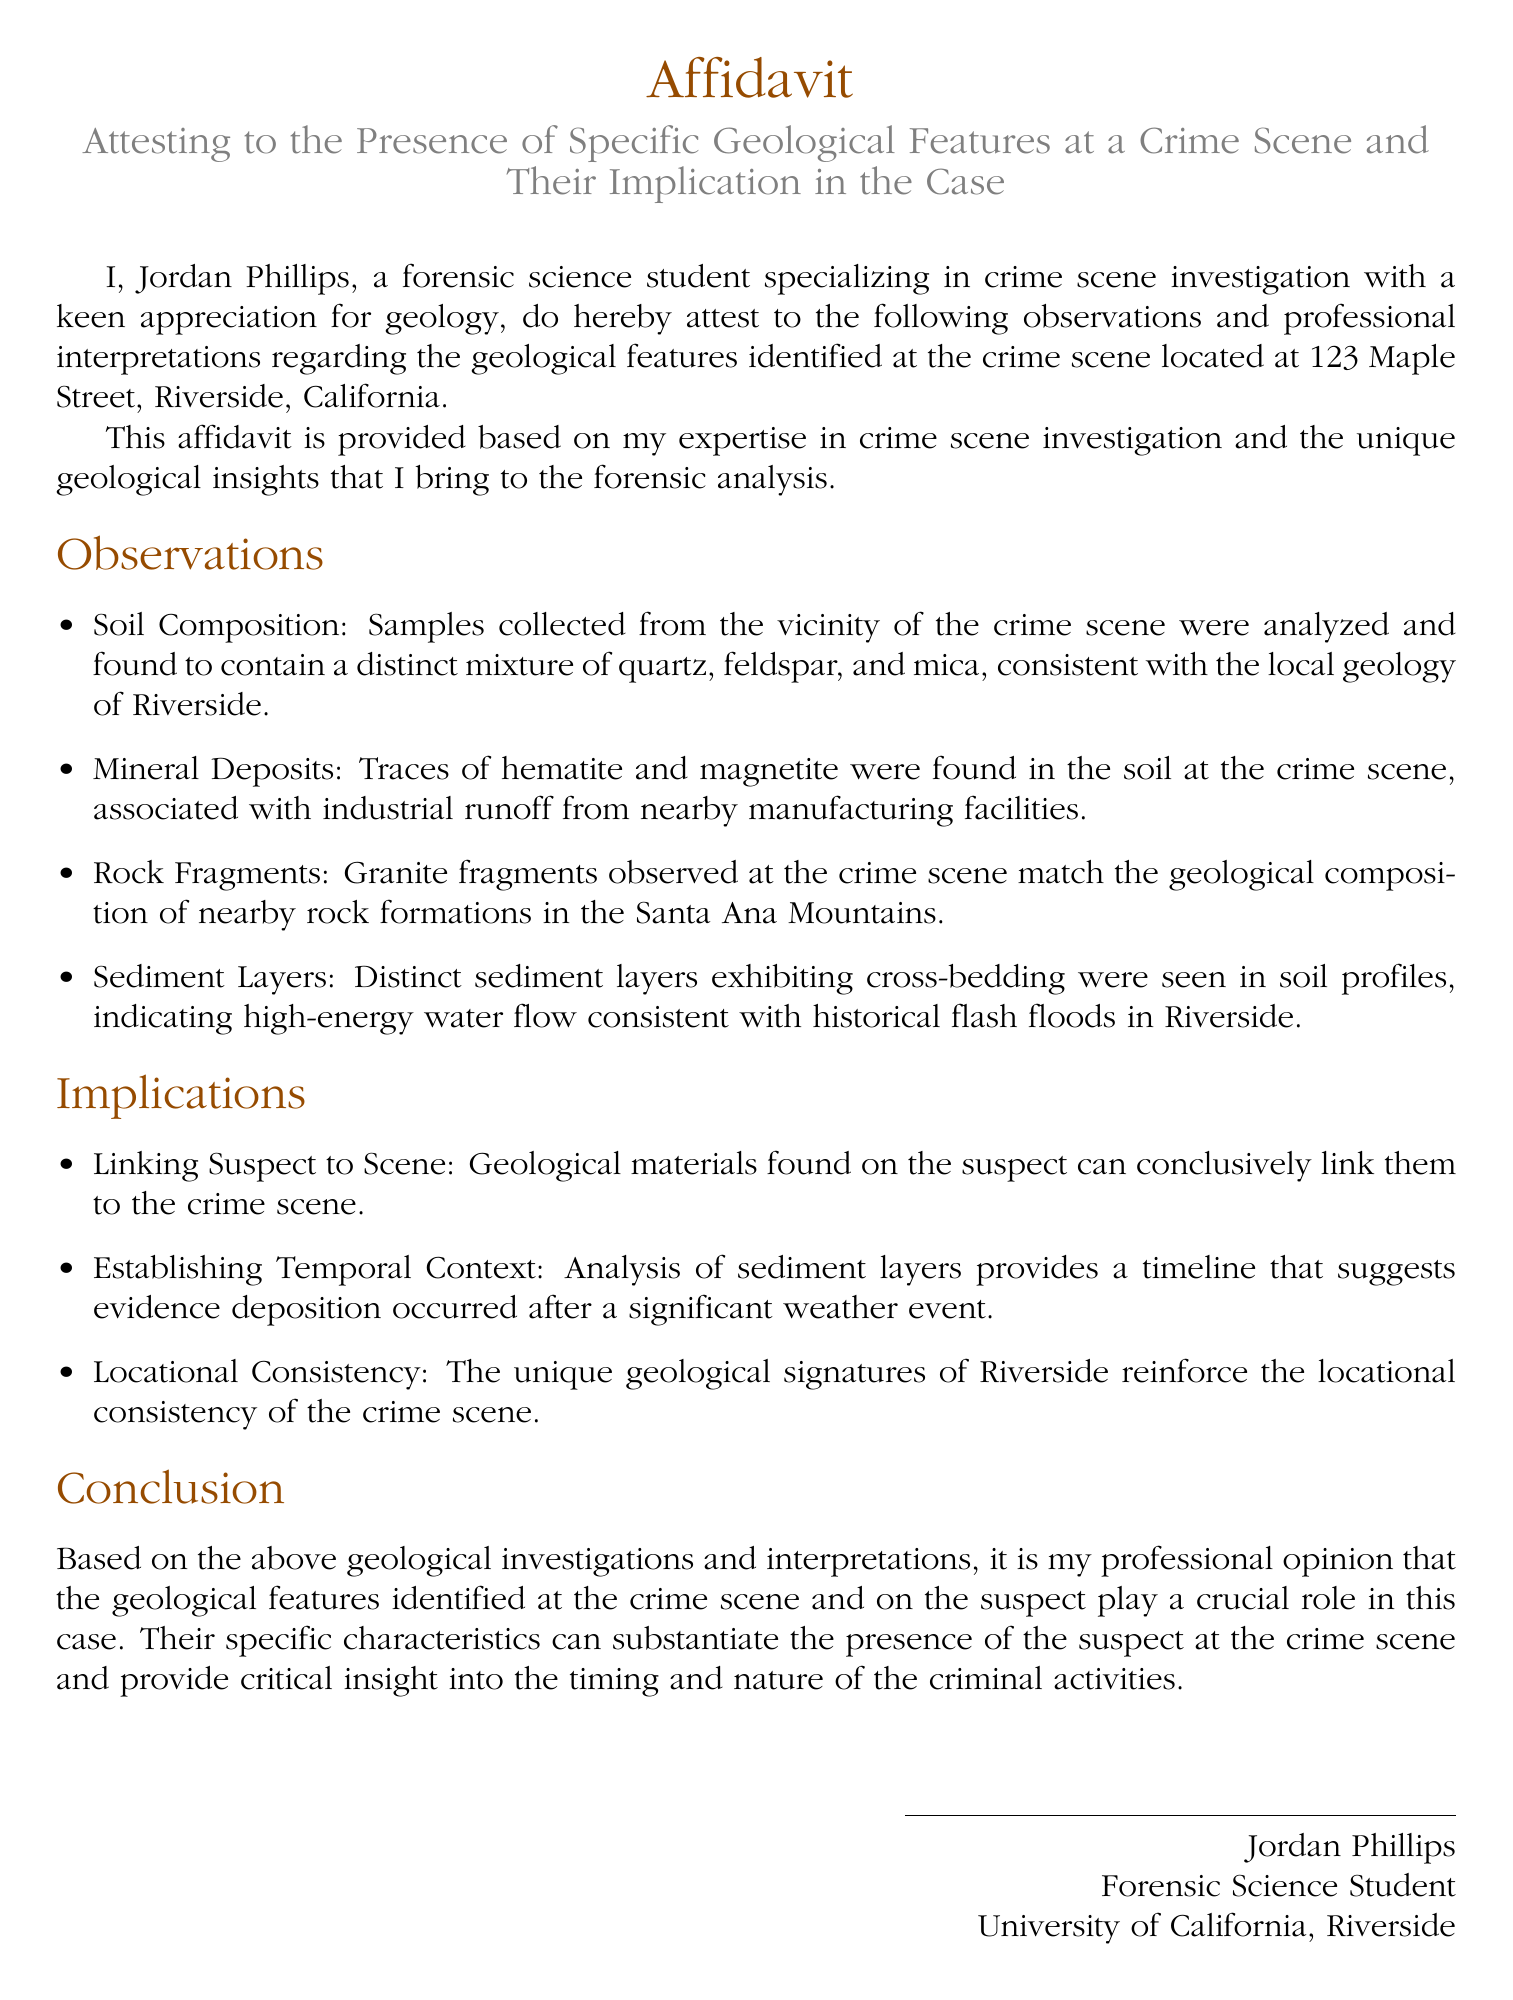What is the name of the affidavit's author? The author of the affidavit is introduced at the beginning, stating their name is Jordan Phillips.
Answer: Jordan Phillips What is the location of the crime scene? The crime scene is specifically stated in the document as being located at 123 Maple Street, Riverside, California.
Answer: 123 Maple Street, Riverside, California What minerals were found in the soil at the crime scene? The affidavit lists hematite and magnetite as the minerals found in the soil at the crime scene.
Answer: Hematite and magnetite Which rock fragments are mentioned in the affidavit? The affidavit notes that granite fragments were observed at the crime scene, specifying their match to nearby rock formations.
Answer: Granite fragments What does the analysis of sediment layers indicate? The sediment layers indicate high-energy water flow consistent with historical flash floods in Riverside.
Answer: High-energy water flow What role do the geological features play in the case, according to the conclusion? The conclusion states that the geological features are crucial in linking the suspect to the crime scene and provide insight into the timing of the events.
Answer: Crucial role How many types of geological features are specifically mentioned in the observations? The observations mention four types of geological features: soil composition, mineral deposits, rock fragments, and sediment layers.
Answer: Four types What is the purpose of this affidavit? The purpose of the affidavit is to attest to specific geological features at a crime scene and their implications in the case.
Answer: Attest to geological features and implications 